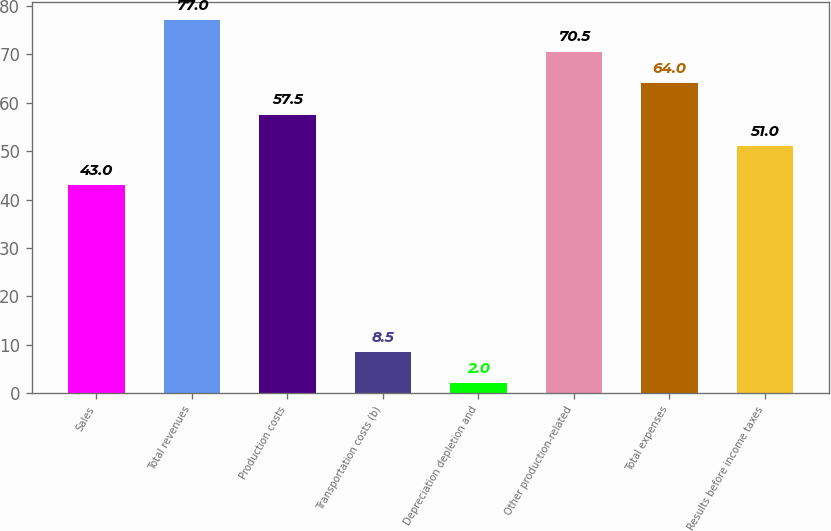<chart> <loc_0><loc_0><loc_500><loc_500><bar_chart><fcel>Sales<fcel>Total revenues<fcel>Production costs<fcel>Transportation costs (b)<fcel>Depreciation depletion and<fcel>Other production-related<fcel>Total expenses<fcel>Results before income taxes<nl><fcel>43<fcel>77<fcel>57.5<fcel>8.5<fcel>2<fcel>70.5<fcel>64<fcel>51<nl></chart> 